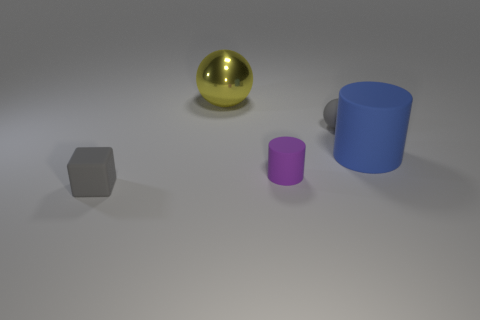The other purple rubber object that is the same shape as the large matte thing is what size?
Give a very brief answer. Small. How many objects are both behind the gray cube and in front of the large yellow metallic thing?
Offer a very short reply. 3. Does the large metal object have the same shape as the matte thing that is behind the large cylinder?
Provide a succinct answer. Yes. Are there more small purple things that are in front of the blue rubber object than large cylinders?
Your answer should be very brief. No. Are there fewer small gray cubes that are in front of the purple object than cyan shiny balls?
Provide a short and direct response. No. What number of other tiny cylinders are the same color as the small matte cylinder?
Give a very brief answer. 0. There is a thing that is behind the blue thing and to the right of the large sphere; what material is it?
Your response must be concise. Rubber. Is the color of the large object behind the big blue object the same as the cylinder on the left side of the large blue cylinder?
Provide a succinct answer. No. How many cyan objects are either shiny objects or tiny matte balls?
Ensure brevity in your answer.  0. Is the number of cylinders in front of the tiny purple rubber object less than the number of big yellow shiny things in front of the big sphere?
Provide a succinct answer. No. 